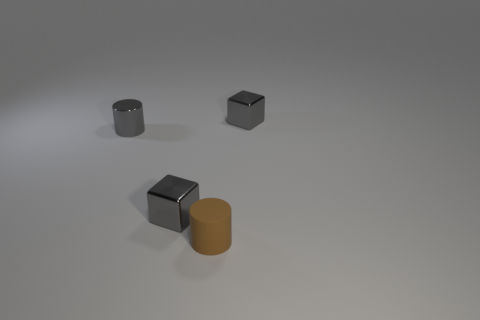Add 4 tiny gray metallic cubes. How many objects exist? 8 Subtract 0 blue cylinders. How many objects are left? 4 Subtract all metal things. Subtract all rubber things. How many objects are left? 0 Add 3 blocks. How many blocks are left? 5 Add 1 large red metal things. How many large red metal things exist? 1 